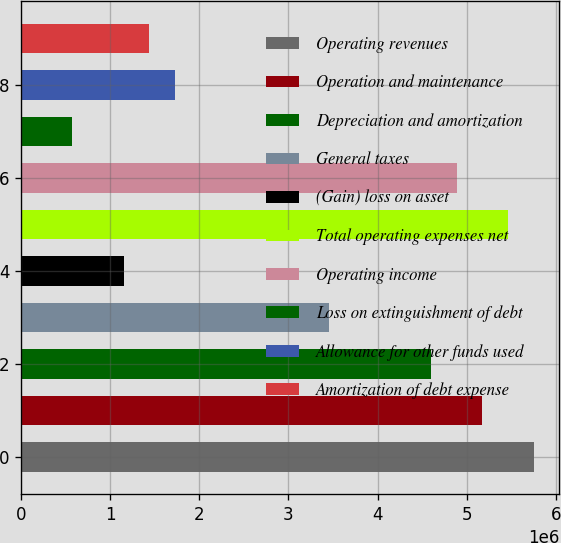Convert chart to OTSL. <chart><loc_0><loc_0><loc_500><loc_500><bar_chart><fcel>Operating revenues<fcel>Operation and maintenance<fcel>Depreciation and amortization<fcel>General taxes<fcel>(Gain) loss on asset<fcel>Total operating expenses net<fcel>Operating income<fcel>Loss on extinguishment of debt<fcel>Allowance for other funds used<fcel>Amortization of debt expense<nl><fcel>5.75378e+06<fcel>5.1784e+06<fcel>4.60302e+06<fcel>3.45227e+06<fcel>1.15076e+06<fcel>5.46609e+06<fcel>4.89071e+06<fcel>575379<fcel>1.72613e+06<fcel>1.43844e+06<nl></chart> 